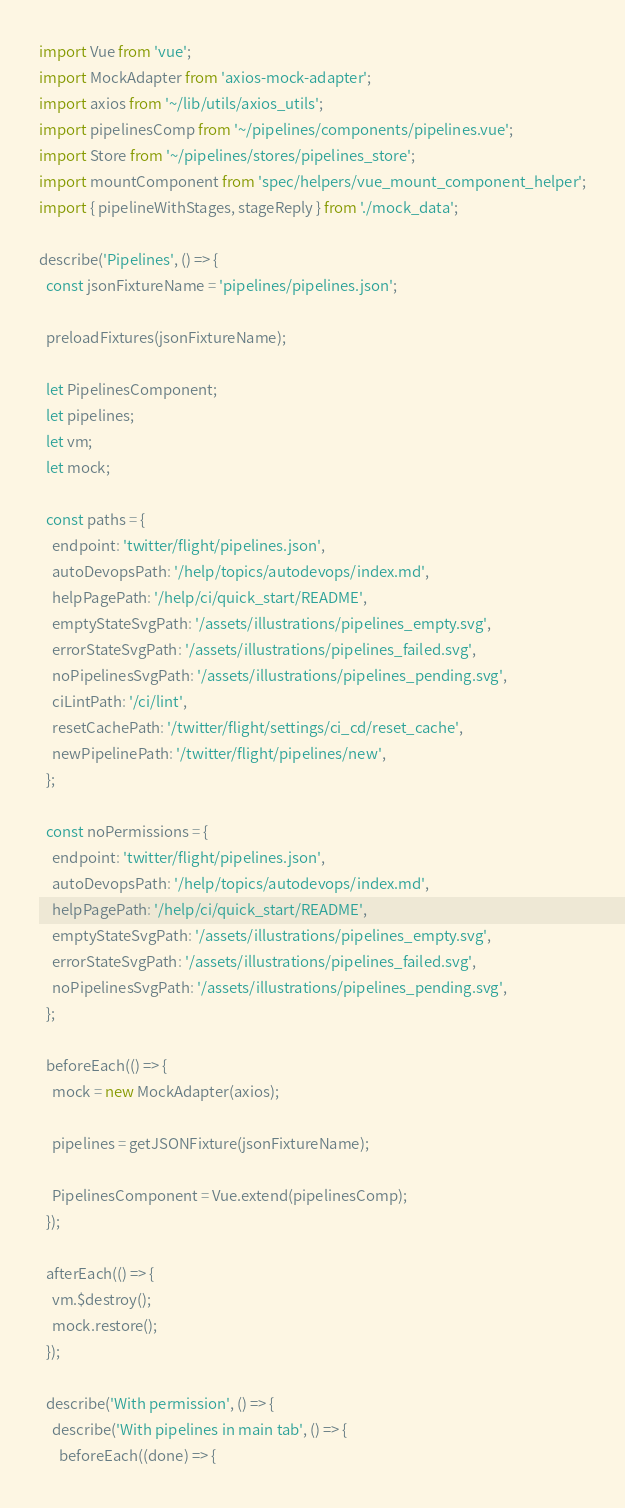<code> <loc_0><loc_0><loc_500><loc_500><_JavaScript_>import Vue from 'vue';
import MockAdapter from 'axios-mock-adapter';
import axios from '~/lib/utils/axios_utils';
import pipelinesComp from '~/pipelines/components/pipelines.vue';
import Store from '~/pipelines/stores/pipelines_store';
import mountComponent from 'spec/helpers/vue_mount_component_helper';
import { pipelineWithStages, stageReply } from './mock_data';

describe('Pipelines', () => {
  const jsonFixtureName = 'pipelines/pipelines.json';

  preloadFixtures(jsonFixtureName);

  let PipelinesComponent;
  let pipelines;
  let vm;
  let mock;

  const paths = {
    endpoint: 'twitter/flight/pipelines.json',
    autoDevopsPath: '/help/topics/autodevops/index.md',
    helpPagePath: '/help/ci/quick_start/README',
    emptyStateSvgPath: '/assets/illustrations/pipelines_empty.svg',
    errorStateSvgPath: '/assets/illustrations/pipelines_failed.svg',
    noPipelinesSvgPath: '/assets/illustrations/pipelines_pending.svg',
    ciLintPath: '/ci/lint',
    resetCachePath: '/twitter/flight/settings/ci_cd/reset_cache',
    newPipelinePath: '/twitter/flight/pipelines/new',
  };

  const noPermissions = {
    endpoint: 'twitter/flight/pipelines.json',
    autoDevopsPath: '/help/topics/autodevops/index.md',
    helpPagePath: '/help/ci/quick_start/README',
    emptyStateSvgPath: '/assets/illustrations/pipelines_empty.svg',
    errorStateSvgPath: '/assets/illustrations/pipelines_failed.svg',
    noPipelinesSvgPath: '/assets/illustrations/pipelines_pending.svg',
  };

  beforeEach(() => {
    mock = new MockAdapter(axios);

    pipelines = getJSONFixture(jsonFixtureName);

    PipelinesComponent = Vue.extend(pipelinesComp);
  });

  afterEach(() => {
    vm.$destroy();
    mock.restore();
  });

  describe('With permission', () => {
    describe('With pipelines in main tab', () => {
      beforeEach((done) => {</code> 